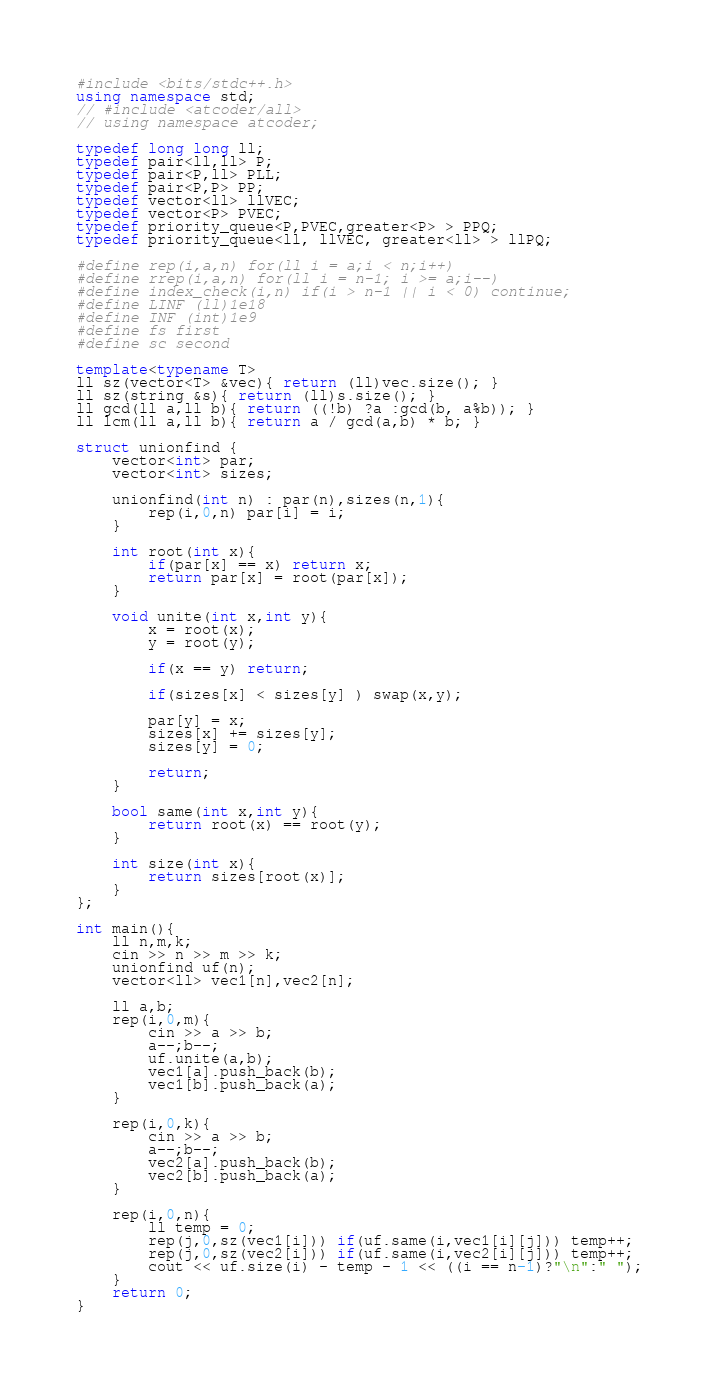<code> <loc_0><loc_0><loc_500><loc_500><_C++_>#include <bits/stdc++.h>
using namespace std;
// #include <atcoder/all>
// using namespace atcoder;

typedef long long ll;
typedef pair<ll,ll> P;
typedef pair<P,ll> PLL;
typedef pair<P,P> PP;
typedef vector<ll> llVEC;
typedef vector<P> PVEC;
typedef priority_queue<P,PVEC,greater<P> > PPQ;
typedef priority_queue<ll, llVEC, greater<ll> > llPQ;

#define rep(i,a,n) for(ll i = a;i < n;i++)
#define rrep(i,a,n) for(ll i = n-1; i >= a;i--)
#define index_check(i,n) if(i > n-1 || i < 0) continue;
#define LINF (ll)1e18
#define INF (int)1e9
#define fs first
#define sc second

template<typename T>
ll sz(vector<T> &vec){ return (ll)vec.size(); }
ll sz(string &s){ return (ll)s.size(); }
ll gcd(ll a,ll b){ return ((!b) ?a :gcd(b, a%b)); }
ll lcm(ll a,ll b){ return a / gcd(a,b) * b; }

struct unionfind {
    vector<int> par;
    vector<int> sizes;

    unionfind(int n) : par(n),sizes(n,1){
        rep(i,0,n) par[i] = i;
    }

    int root(int x){
        if(par[x] == x) return x;
        return par[x] = root(par[x]);
    }

    void unite(int x,int y){
        x = root(x);
        y = root(y);

        if(x == y) return;

        if(sizes[x] < sizes[y] ) swap(x,y);

        par[y] = x;
        sizes[x] += sizes[y];
        sizes[y] = 0;

        return;
    }

    bool same(int x,int y){
        return root(x) == root(y);
    }

    int size(int x){
        return sizes[root(x)];
    }
};

int main(){
    ll n,m,k;
    cin >> n >> m >> k;
    unionfind uf(n);
    vector<ll> vec1[n],vec2[n];

    ll a,b;
    rep(i,0,m){
        cin >> a >> b;
        a--;b--;
        uf.unite(a,b);
        vec1[a].push_back(b);
        vec1[b].push_back(a);
    }

    rep(i,0,k){
        cin >> a >> b;
        a--;b--;
        vec2[a].push_back(b);
        vec2[b].push_back(a);
    }

    rep(i,0,n){
        ll temp = 0;
        rep(j,0,sz(vec1[i])) if(uf.same(i,vec1[i][j])) temp++;
        rep(j,0,sz(vec2[i])) if(uf.same(i,vec2[i][j])) temp++;
        cout << uf.size(i) - temp - 1 << ((i == n-1)?"\n":" ");
    }
    return 0;
}
</code> 